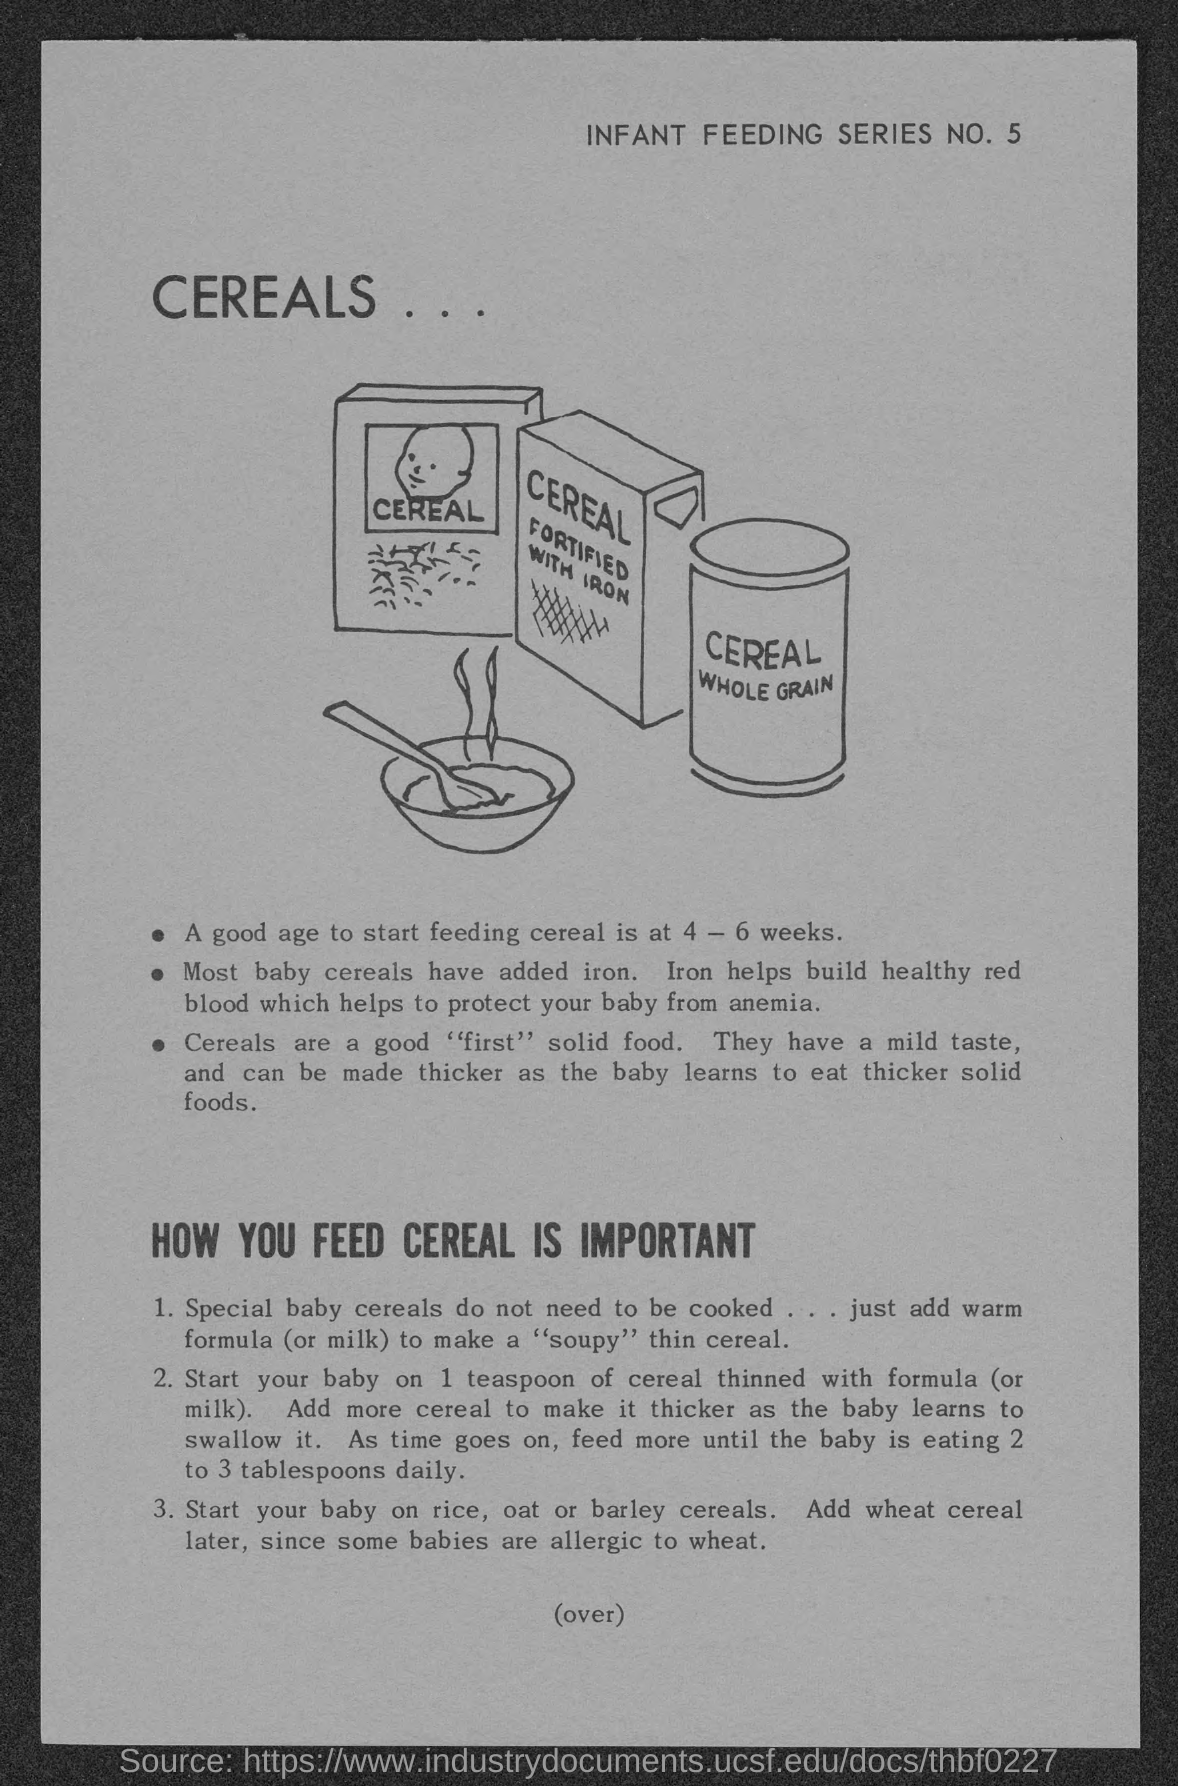Highlight a few significant elements in this photo. The heading at the top of the page is "Cereals. 